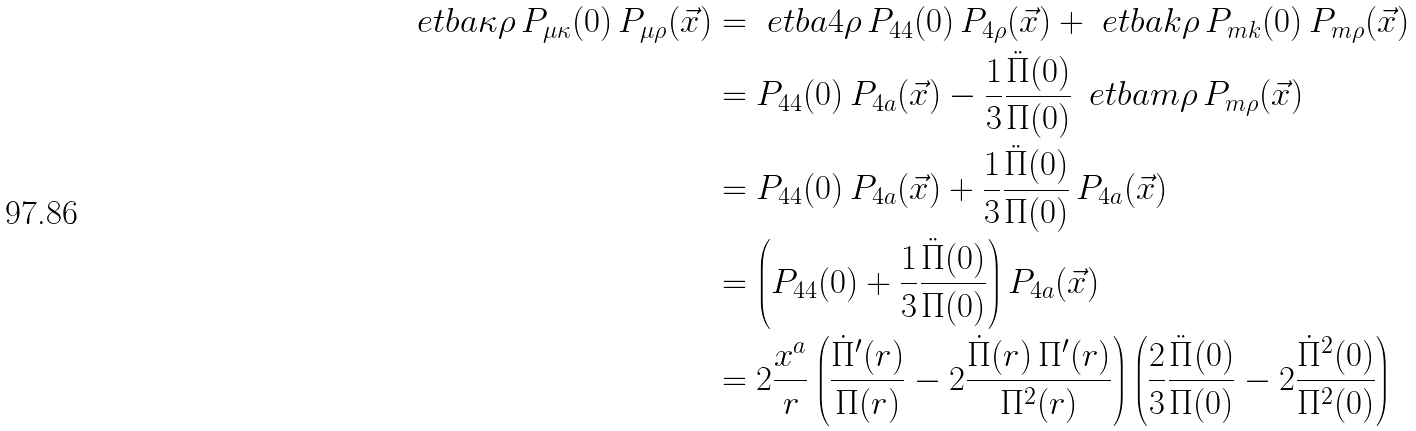<formula> <loc_0><loc_0><loc_500><loc_500>\ e t b a \kappa \rho \, P _ { \mu \kappa } ( 0 ) \, P _ { \mu \rho } ( \vec { x } ) & = \ e t b a 4 \rho \, P _ { 4 4 } ( 0 ) \, P _ { 4 \rho } ( \vec { x } ) + \ e t b a k \rho \, P _ { m k } ( 0 ) \, P _ { m \rho } ( \vec { x } ) \\ & = P _ { 4 4 } ( 0 ) \, P _ { 4 a } ( \vec { x } ) - \frac { 1 } { 3 } \frac { \ddot { \Pi } ( 0 ) } { \Pi ( 0 ) } \, \ e t b a m \rho \, P _ { m \rho } ( \vec { x } ) \\ & = P _ { 4 4 } ( 0 ) \, P _ { 4 a } ( \vec { x } ) + \frac { 1 } { 3 } \frac { \ddot { \Pi } ( 0 ) } { \Pi ( 0 ) } \, P _ { 4 a } ( \vec { x } ) \\ & = \left ( P _ { 4 4 } ( 0 ) + \frac { 1 } { 3 } \frac { \ddot { \Pi } ( 0 ) } { \Pi ( 0 ) } \right ) P _ { 4 a } ( \vec { x } ) \\ & = 2 \frac { x ^ { a } } r \left ( \frac { \dot { \Pi } ^ { \prime } ( r ) } { \Pi ( r ) } - 2 \frac { \dot { \Pi } ( r ) \, \Pi ^ { \prime } ( r ) } { \Pi ^ { 2 } ( r ) } \right ) \left ( \frac { 2 } { 3 } \frac { \ddot { \Pi } ( 0 ) } { \Pi ( 0 ) } - 2 \frac { \dot { \Pi } ^ { 2 } ( 0 ) } { \Pi ^ { 2 } ( 0 ) } \right )</formula> 